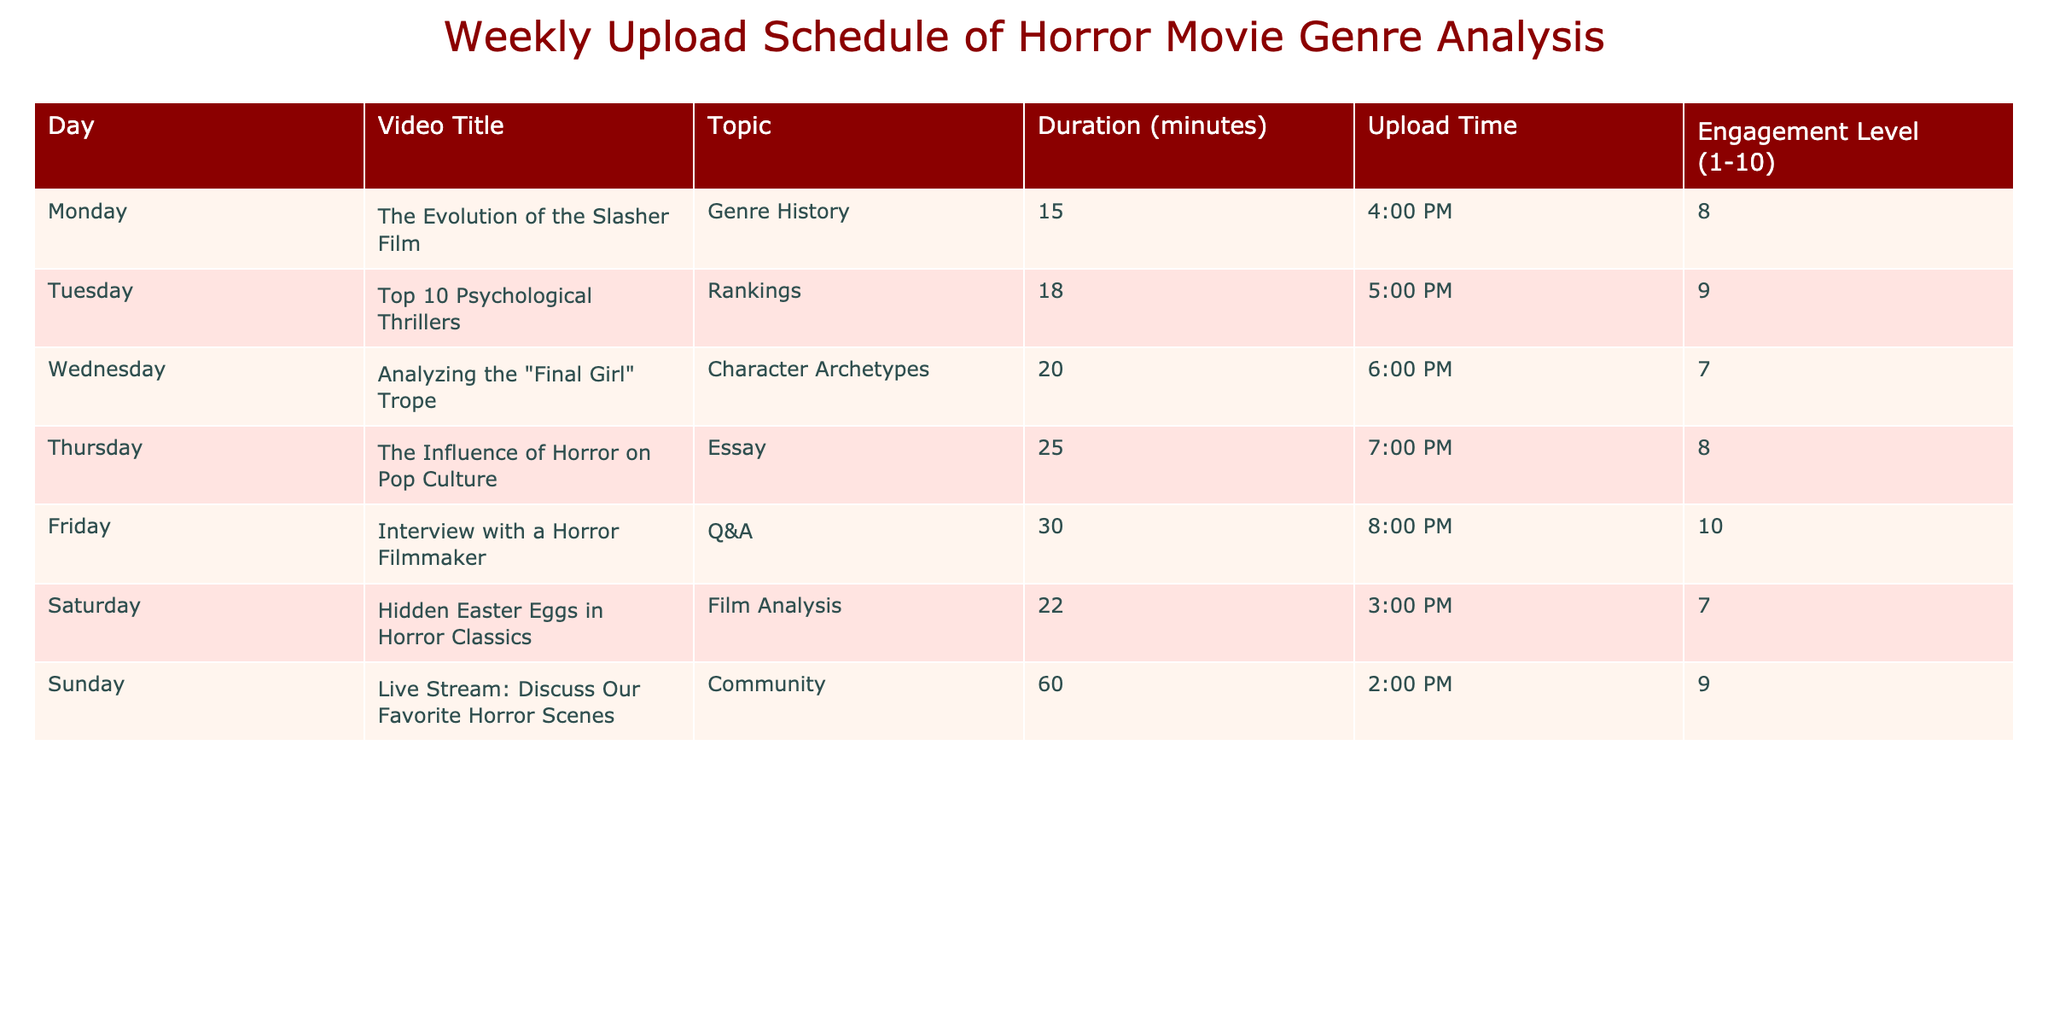What video has the highest engagement level? Looking at the "Engagement Level" column, the highest value is 10 for "Interview with a Horror Filmmaker," which is on Friday.
Answer: Interview with a Horror Filmmaker Which video has the longest duration? By checking the "Duration" column, the longest video listed is "Interview with a Horror Filmmaker" with a duration of 30 minutes.
Answer: Interview with a Horror Filmmaker What is the average engagement level of the videos uploaded on weekdays? The videos from Monday to Friday have engagement levels of 8, 9, 7, 8, and 10, respectively. Summing these gives 8 + 9 + 7 + 8 + 10 = 42. There are 5 videos, so the average is 42 / 5 = 8.4.
Answer: 8.4 On which day is the shortest video uploaded? The shortest video listed in the "Duration" column is "The Evolution of the Slasher Film," which is 15 minutes long and is uploaded on Monday.
Answer: Monday True or false: The video discussing the “Final Girl” trope has an engagement level lower than 8. The engagement level for "Analyzing the 'Final Girl' Trope" is 7, which is indeed lower than 8. Hence, this statement is true.
Answer: True What is the total duration of all videos uploaded on the weekend? The videos scheduled for Saturday and Sunday are "Hidden Easter Eggs in Horror Classics" (22 minutes) and "Live Stream: Discuss Our Favorite Horror Scenes" (60 minutes). Adding these gives 22 + 60 = 82 minutes.
Answer: 82 minutes Which video has its upload time closest to 5:00 PM? Looking at the "Upload Time" column, the video "Top 10 Psychological Thrillers" is uploaded at 5:00 PM, which is the exact time, making it the one closest to 5:00 PM.
Answer: Top 10 Psychological Thrillers How many videos discuss character archetypes? The only video that addresses character archetypes is "Analyzing the 'Final Girl' Trope," which appears just once in the table.
Answer: 1 What is the difference in engagement levels between the highest and lowest rated videos? The highest engagement level is 10 for "Interview with a Horror Filmmaker" and the lowest is 7 for both "Analyzing the 'Final Girl' Trope" and "Hidden Easter Eggs in Horror Classics." The difference is 10 - 7 = 3.
Answer: 3 